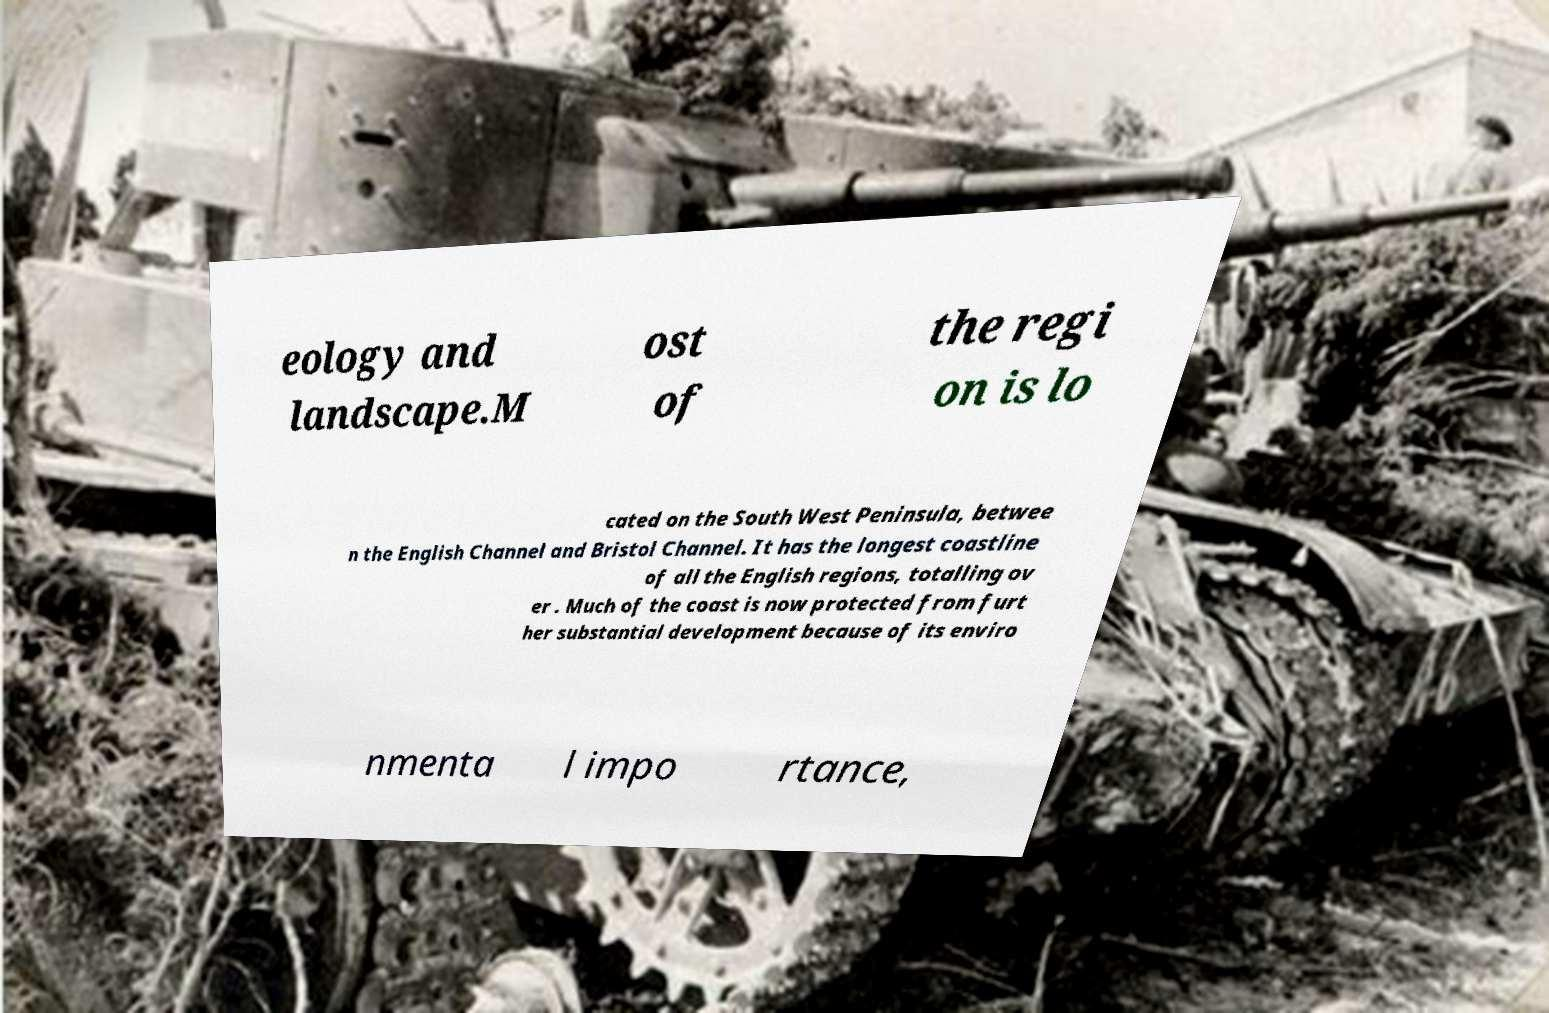Can you read and provide the text displayed in the image?This photo seems to have some interesting text. Can you extract and type it out for me? eology and landscape.M ost of the regi on is lo cated on the South West Peninsula, betwee n the English Channel and Bristol Channel. It has the longest coastline of all the English regions, totalling ov er . Much of the coast is now protected from furt her substantial development because of its enviro nmenta l impo rtance, 